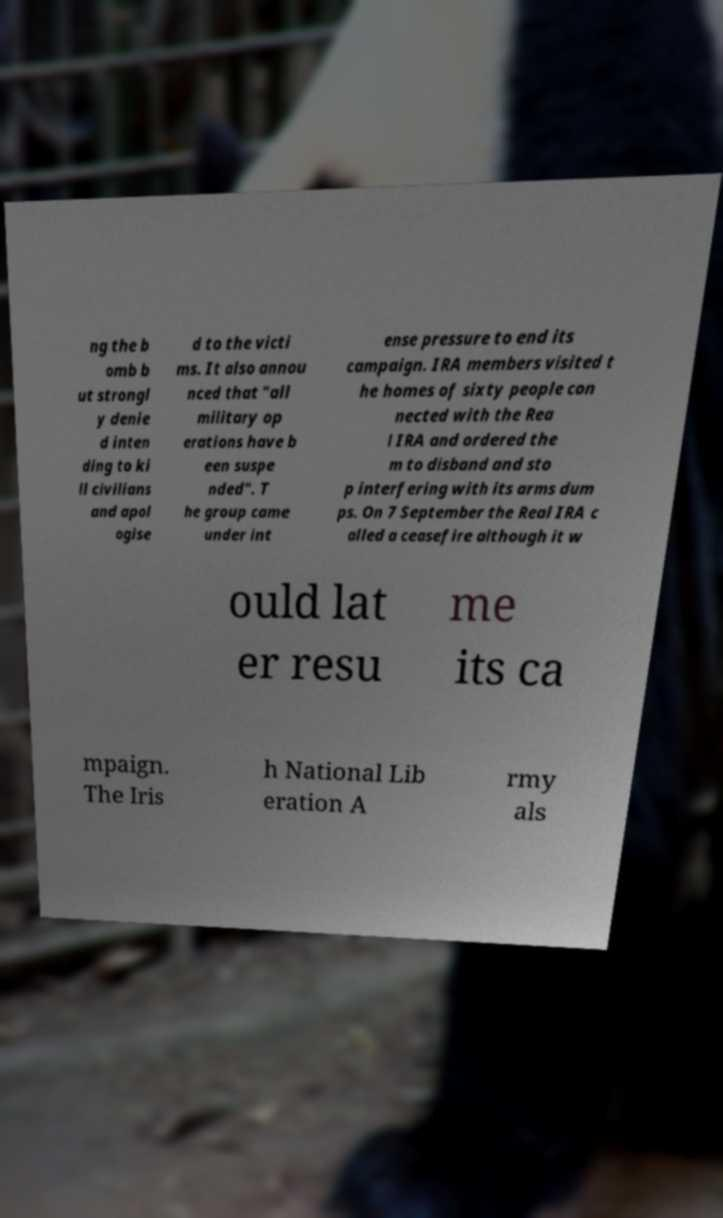Could you extract and type out the text from this image? ng the b omb b ut strongl y denie d inten ding to ki ll civilians and apol ogise d to the victi ms. It also annou nced that "all military op erations have b een suspe nded". T he group came under int ense pressure to end its campaign. IRA members visited t he homes of sixty people con nected with the Rea l IRA and ordered the m to disband and sto p interfering with its arms dum ps. On 7 September the Real IRA c alled a ceasefire although it w ould lat er resu me its ca mpaign. The Iris h National Lib eration A rmy als 